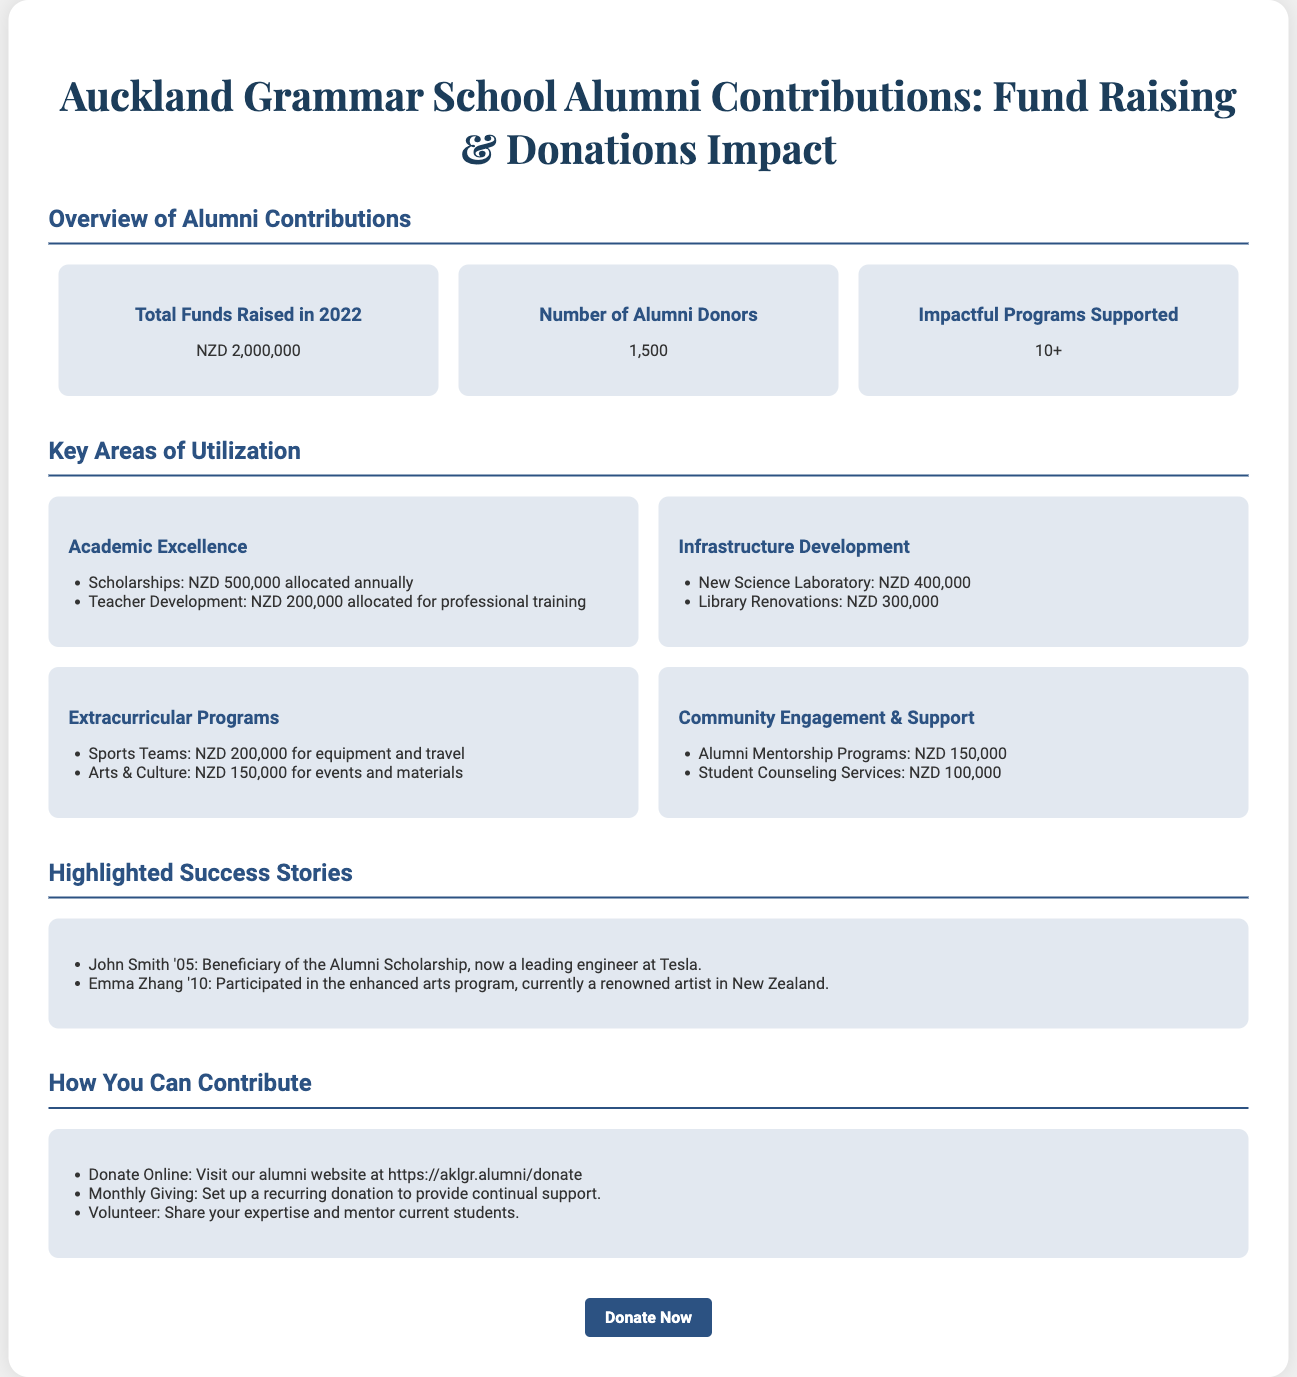What is the total funds raised in 2022? The total funds raised in 2022 is stated as NZD 2,000,000 in the overview section.
Answer: NZD 2,000,000 How many alumni donors contributed? The document specifies that there are 1,500 alumni donors who contributed.
Answer: 1,500 What amount is allocated for scholarships annually? The document states that NZD 500,000 is allocated annually for scholarships under Academic Excellence.
Answer: NZD 500,000 What new facility was funded with NZD 400,000? The document mentions that the new Science Laboratory was funded with NZD 400,000 in the Infrastructure Development section.
Answer: New Science Laboratory Which program received NZD 150,000? The Arts & Culture program received NZD 150,000 for events and materials as mentioned under Extracurricular Programs.
Answer: Arts & Culture Who is John Smith and what is his achievement? The document highlights John Smith as a beneficiary of the Alumni Scholarship and now a leading engineer at Tesla.
Answer: Beneficiary of the Alumni Scholarship, now a leading engineer at Tesla What type of support does the alumni contribute to for student counseling? The document mentions that NZD 100,000 is allocated for Student Counseling Services under Community Engagement & Support.
Answer: Student Counseling Services How can one donate online? The document provides the alumni website link for online donations.
Answer: Visit our alumni website at https://aklgr.alumni/donate What is one way alumni can offer continuous support? The document mentions setting up a recurring donation as a way to provide continual support.
Answer: Monthly Giving 